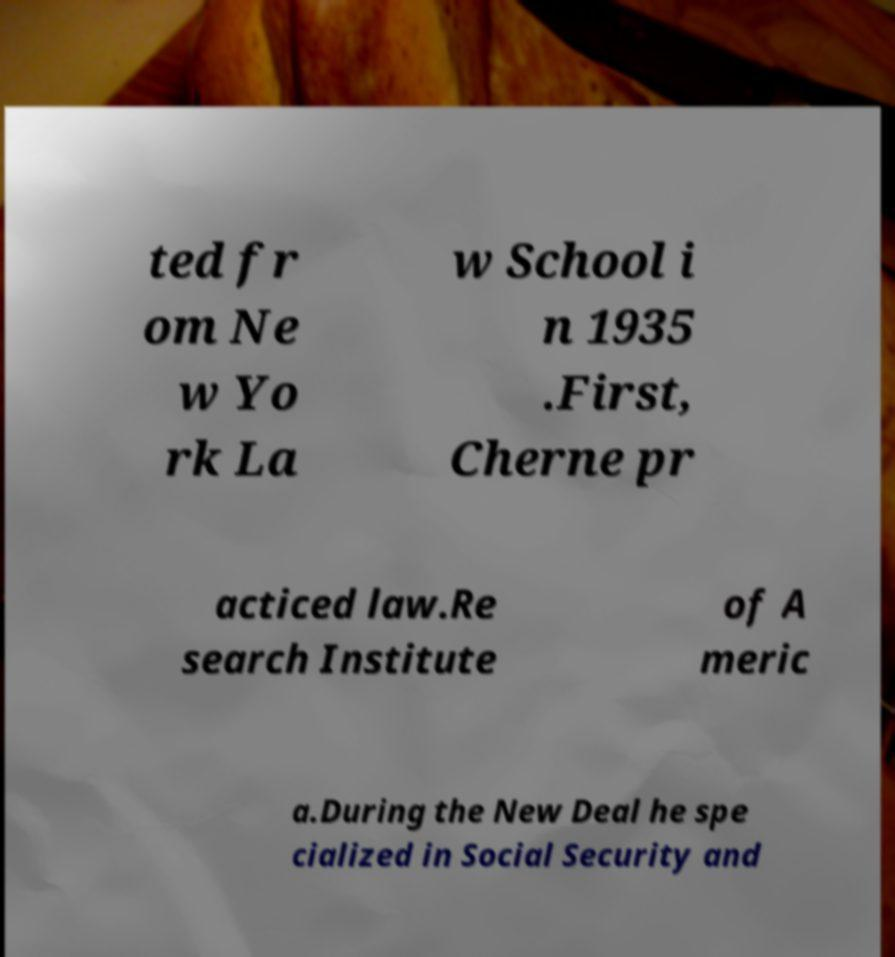Can you accurately transcribe the text from the provided image for me? ted fr om Ne w Yo rk La w School i n 1935 .First, Cherne pr acticed law.Re search Institute of A meric a.During the New Deal he spe cialized in Social Security and 